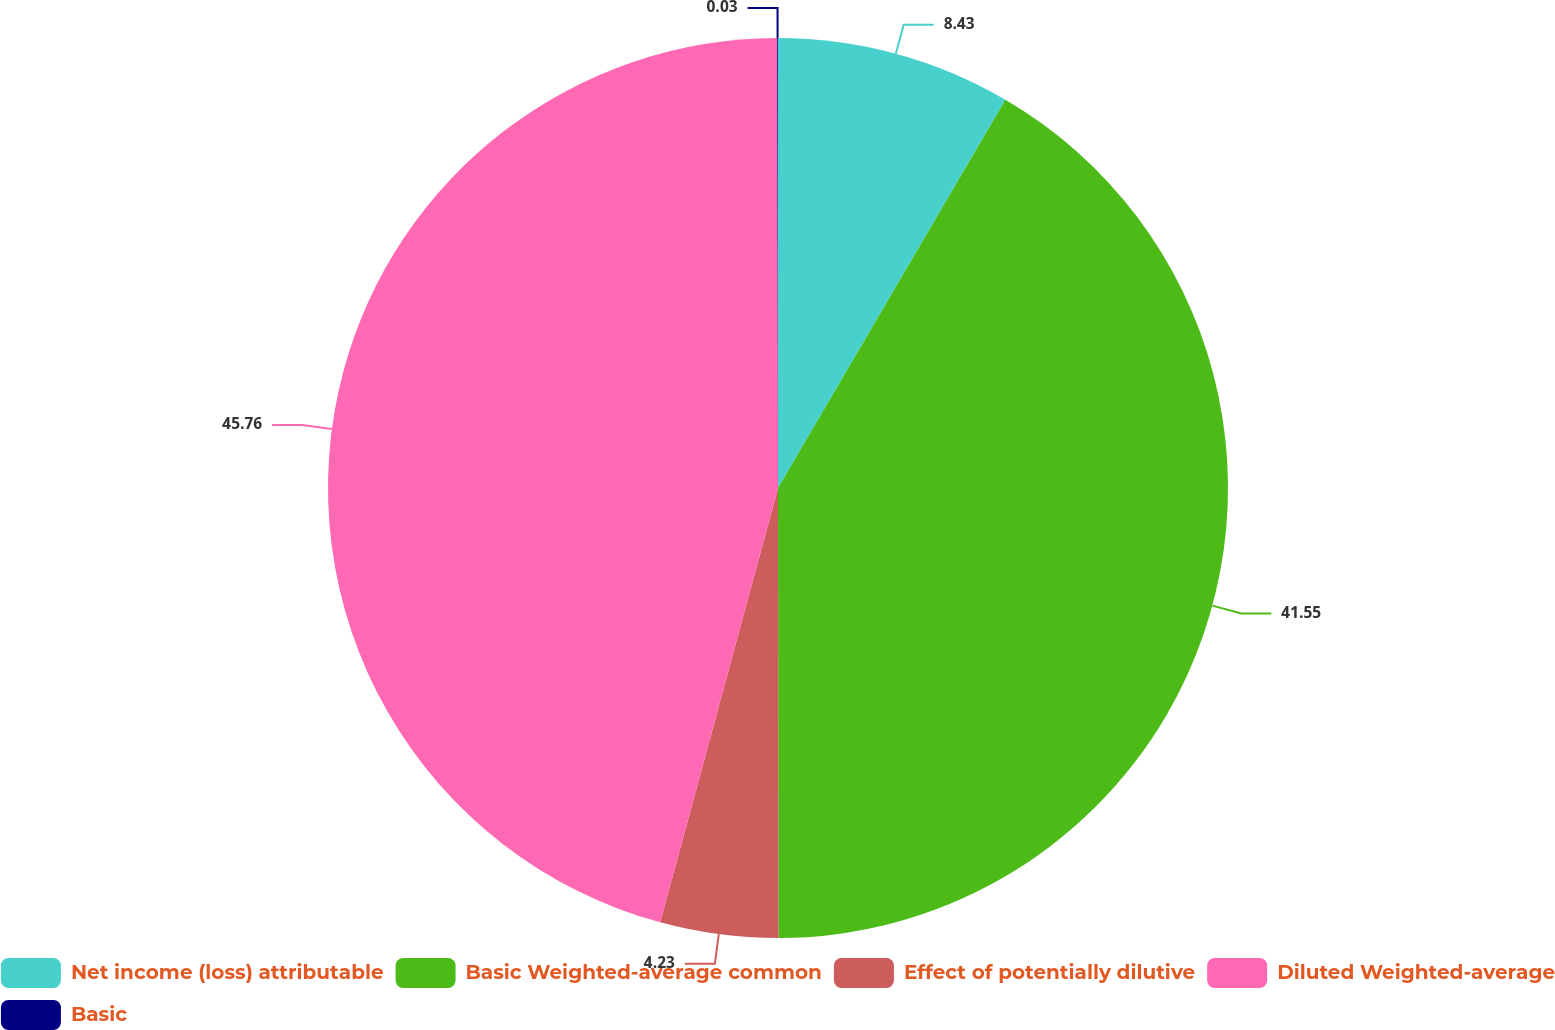<chart> <loc_0><loc_0><loc_500><loc_500><pie_chart><fcel>Net income (loss) attributable<fcel>Basic Weighted-average common<fcel>Effect of potentially dilutive<fcel>Diluted Weighted-average<fcel>Basic<nl><fcel>8.43%<fcel>41.55%<fcel>4.23%<fcel>45.75%<fcel>0.03%<nl></chart> 